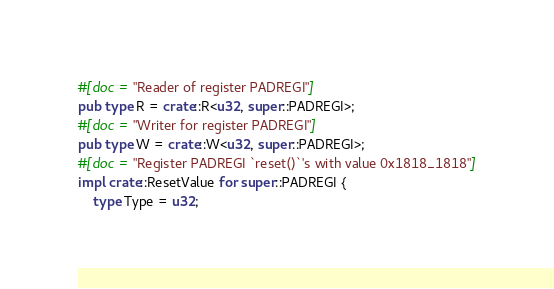<code> <loc_0><loc_0><loc_500><loc_500><_Rust_>#[doc = "Reader of register PADREGI"]
pub type R = crate::R<u32, super::PADREGI>;
#[doc = "Writer for register PADREGI"]
pub type W = crate::W<u32, super::PADREGI>;
#[doc = "Register PADREGI `reset()`'s with value 0x1818_1818"]
impl crate::ResetValue for super::PADREGI {
    type Type = u32;</code> 